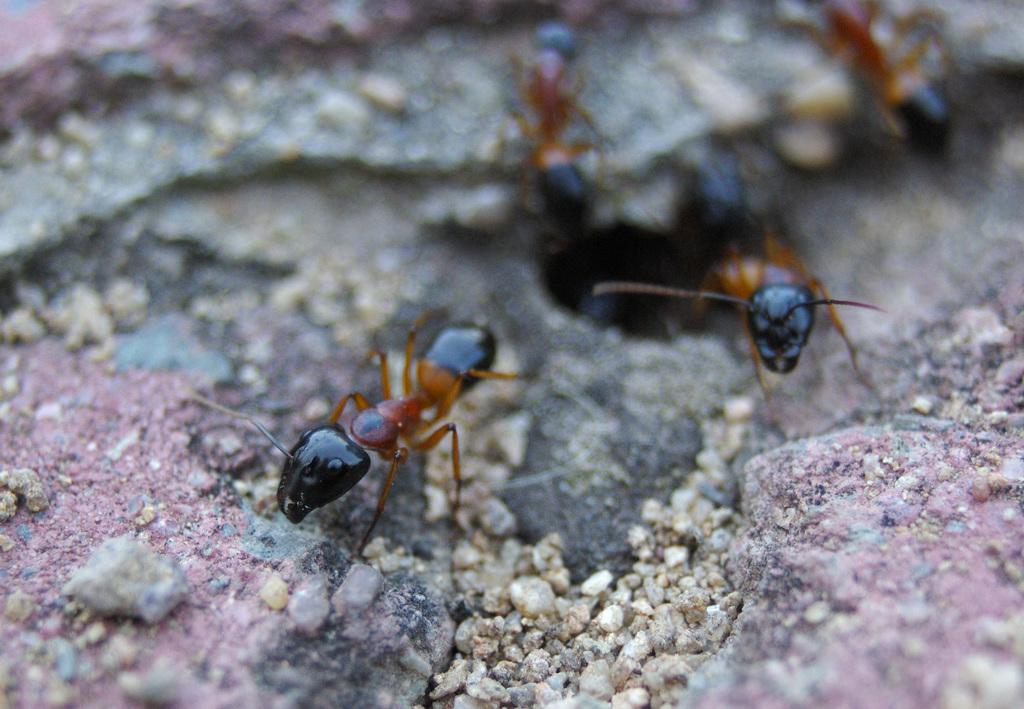What type of creatures can be seen on the ground in the image? There are ants on the ground in the image. What can be found in the foreground of the image? There are stones in the foreground of the image. What type of wool can be seen in the image? There is no wool present in the image. How many fish are visible in the image? There are no fish present in the image. 